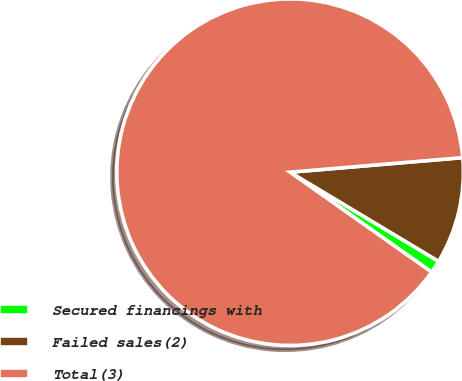<chart> <loc_0><loc_0><loc_500><loc_500><pie_chart><fcel>Secured financings with<fcel>Failed sales(2)<fcel>Total(3)<nl><fcel>1.18%<fcel>9.94%<fcel>88.88%<nl></chart> 